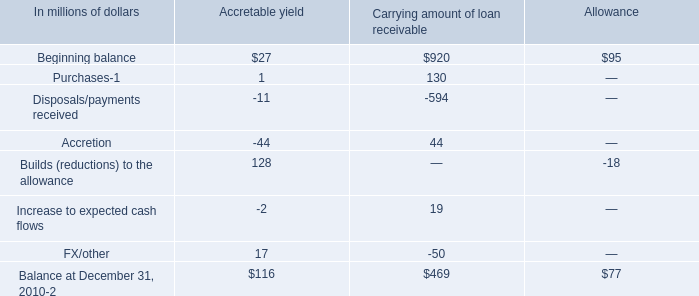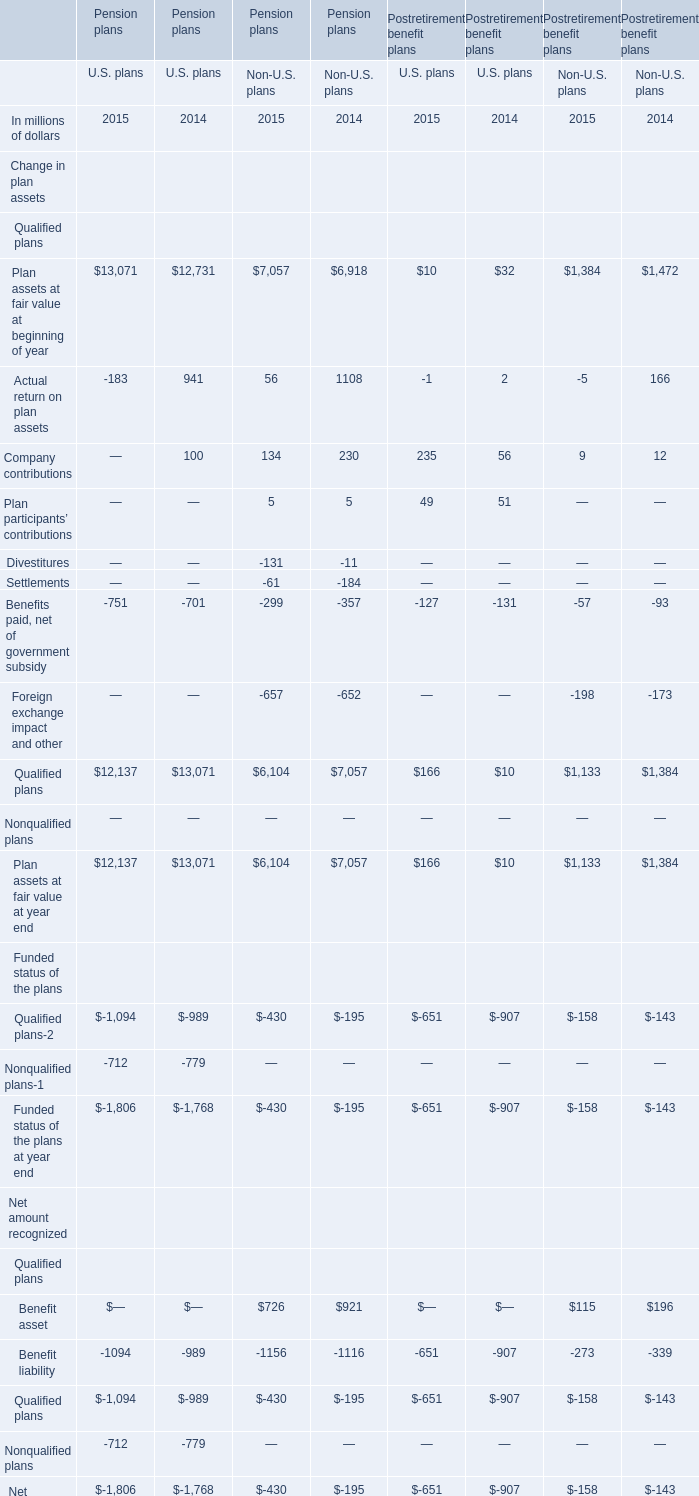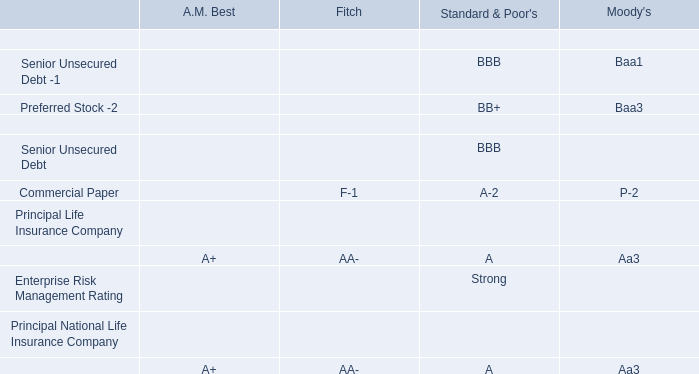what is the gross carrying amount in millions of the company's purchased distressed loan portfolio at december 31 , 2010? 
Computations: (392 + 77)
Answer: 469.0. 